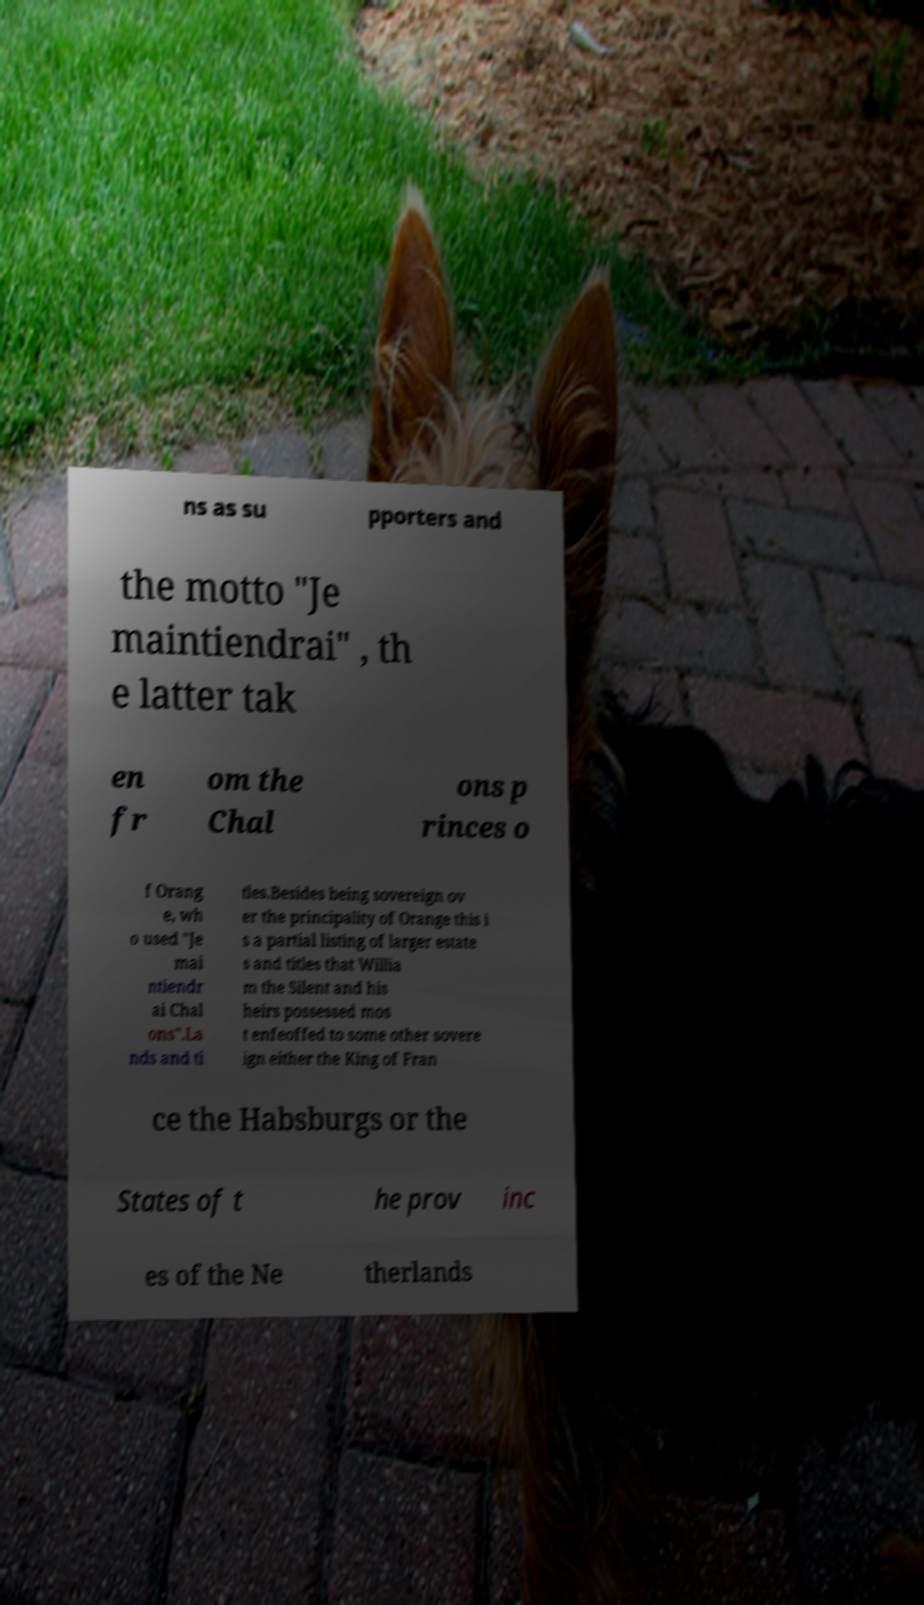Can you accurately transcribe the text from the provided image for me? ns as su pporters and the motto "Je maintiendrai" , th e latter tak en fr om the Chal ons p rinces o f Orang e, wh o used "Je mai ntiendr ai Chal ons".La nds and ti tles.Besides being sovereign ov er the principality of Orange this i s a partial listing of larger estate s and titles that Willia m the Silent and his heirs possessed mos t enfeoffed to some other sovere ign either the King of Fran ce the Habsburgs or the States of t he prov inc es of the Ne therlands 